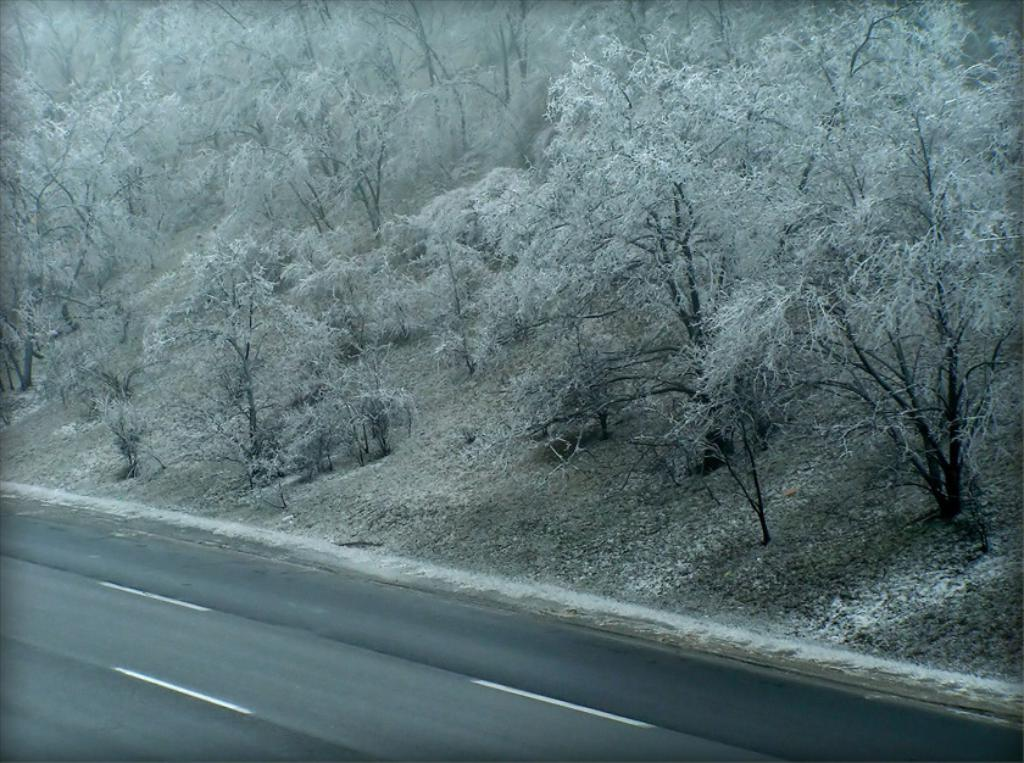What is the main feature of the image? There is a road in the picture. Can you describe the road in more detail? The road has white stripes on it. What can be seen in the background of the picture? There are trees in the background of the picture. Can you tell me how many volleyballs are visible on the road in the image? There are no volleyballs visible on the road in the image. Is there a farmer driving a tractor on the road in the image? There is no farmer or tractor present in the image. 